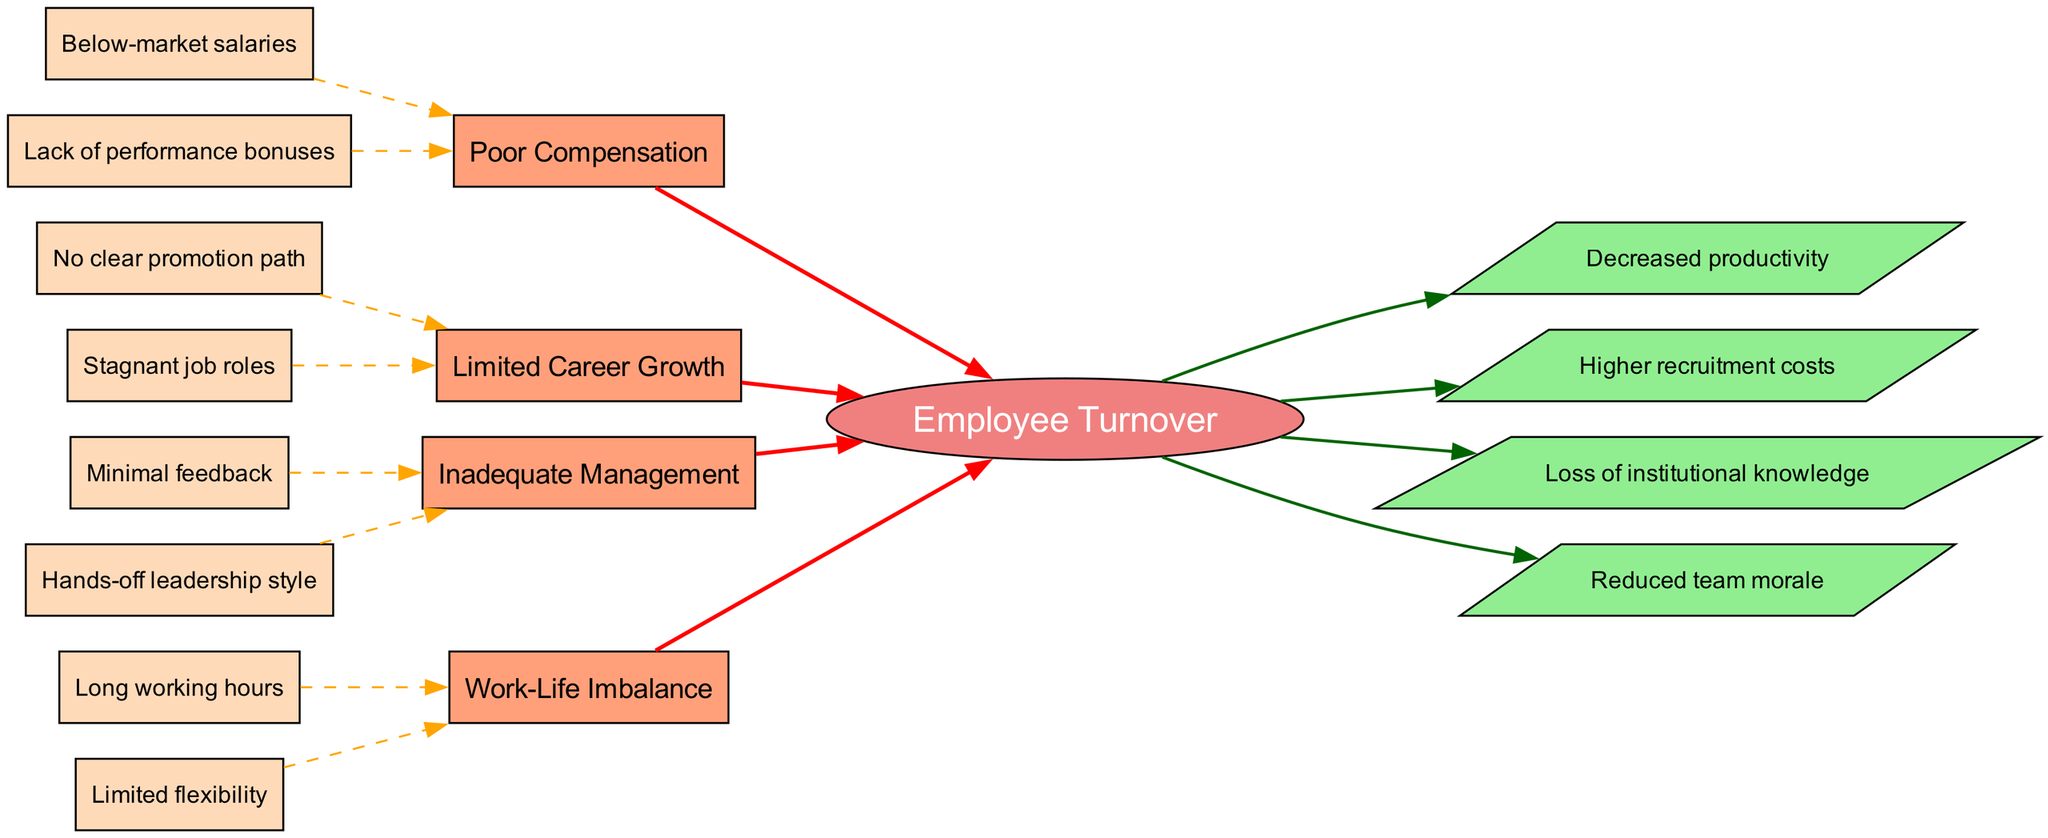What is the central theme of the diagram? The central theme node, represented as an ellipse, contains the text "Employee Turnover," which is central to the diagram's analysis.
Answer: Employee Turnover How many main causes contribute to employee turnover in the diagram? The diagram lists four main causes, each represented by a rectangular node connected to the central theme. Specifically, they are Poor Compensation, Limited Career Growth, Inadequate Management, and Work-Life Imbalance.
Answer: 4 What sub-cause is associated with inadequate management? The diagram identifies two sub-causes under inadequate management, one of which is "Minimum feedback." The answer is taken directly from the dashed edges connecting sub-causes to their respective main cause node.
Answer: Minimal feedback Which business impact is directly linked to employee turnover? Among the business impacts, "Decreased productivity" is connected to the central theme node, indicating a direct relationship with employee turnover. This is identified by following the arrow leading from the central theme to the parallel node labeled "Decreased productivity."
Answer: Decreased productivity What is the color of the nodes for the main causes? The main causes are all represented by rectangular nodes filled with the color "lightsalmon," as specified in the graph rendering configuration.
Answer: lightsalmon What is the relationship between "Limited flexibility" and "Work-Life Imbalance"? "Limited flexibility" is a sub-cause of "Work-Life Imbalance," indicated by the dashed edge connecting the sub-cause node to the main cause node labeled "Work-Life Imbalance."
Answer: Sub-cause Which business impact is associated with increased employee turnover costs? The diagram indicates "Higher recruitment costs" as one of the business impacts connected to employee turnover. This is determined by observing the parallel nodes connected to the central theme labeled with various business impacts.
Answer: Higher recruitment costs What is the total number of business impacts listed in the diagram? The diagram lists four business impacts, each represented by a parallelogram node, giving a clear indication of their quantity. The impacts are Decreased productivity, Higher recruitment costs, Loss of institutional knowledge, and Reduced team morale.
Answer: 4 Which sub-cause relates to poor compensation? The diagram highlights "Below-market salaries" as a sub-cause associated with the main cause of "Poor Compensation," directly illustrated by the dashed edge connecting the sub-cause to its respective main cause node.
Answer: Below-market salaries What type of leadership style is identified as a contributor to inadequate management? The diagram mentions "Hands-off leadership style" under the inadequate management main cause, linked through a dashed edge, signifying it as a sub-cause.
Answer: Hands-off leadership style 